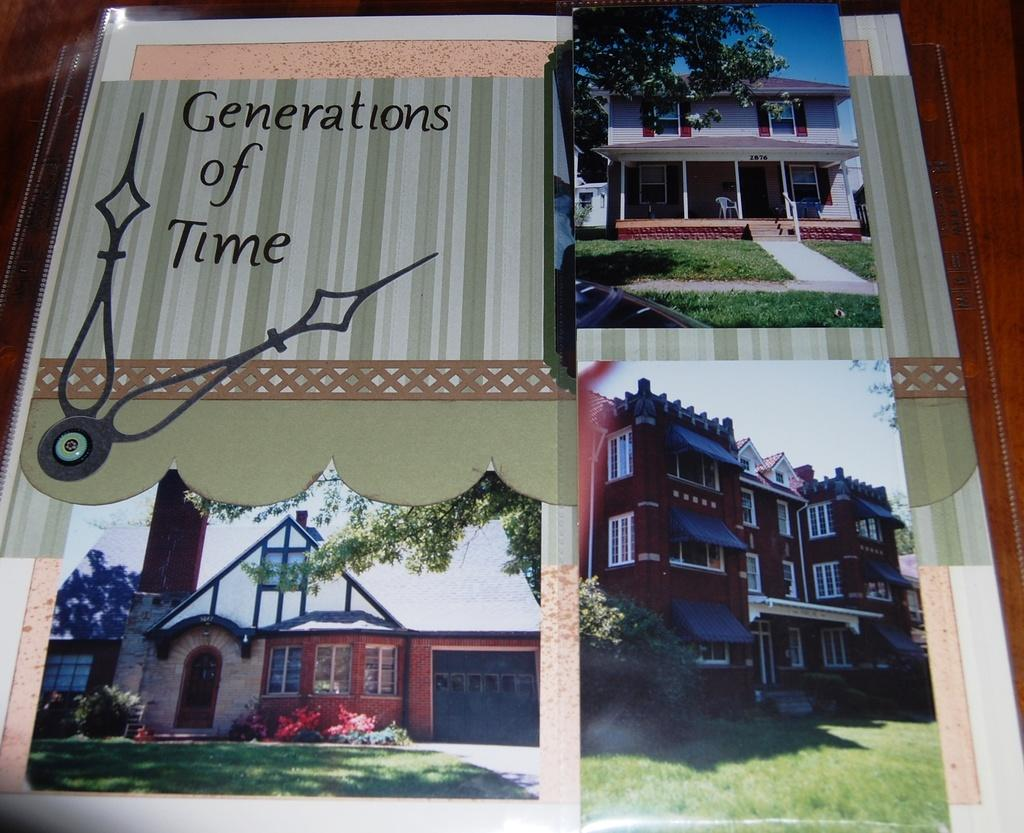What is the main subject of the poster in the image? The poster contains pictures of buildings, trees, and green grass. Where is the poster located in the image? The poster is kept on a table. What is written on the poster? There is text on the left side of the poster. What type of toothpaste is advertised in the poster? There is no toothpaste advertised in the poster; it contains pictures of buildings, trees, and green grass, along with text. Can you see any dirt in the park depicted on the poster? There is no park depicted on the poster; it contains pictures of buildings, trees, and green grass. 